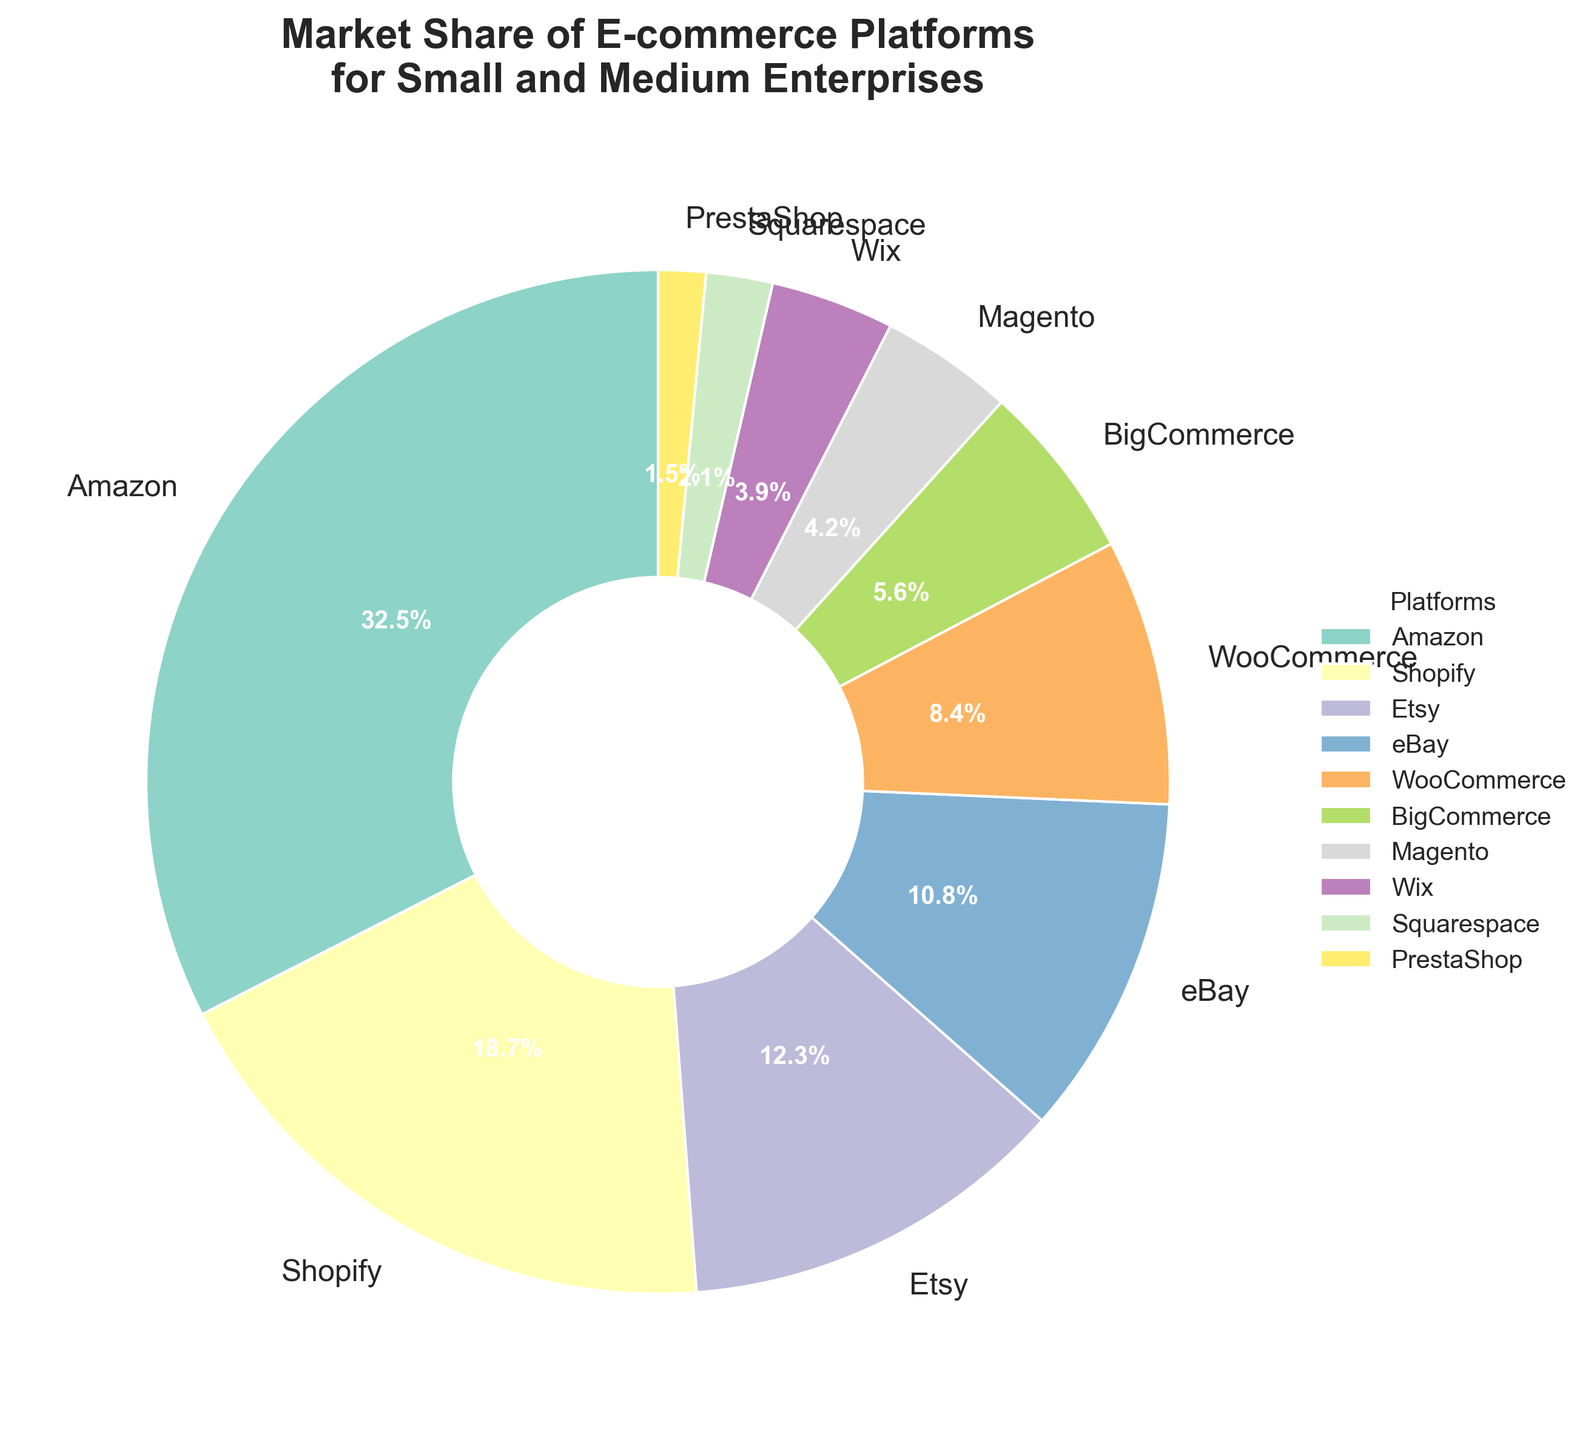Which e-commerce platform has the largest market share? By looking at the pie chart, we can see which platform occupies the largest segment. Amazon is the largest segment in the chart.
Answer: Amazon Which two platforms have a combined market share closest to 50%? We need to sum the market shares of different pairs and find the pair whose sum is closest to 50%. Amazon (32.5%) and Shopify (18.7%) together make 51.2%, which is closest to 50%.
Answer: Amazon and Shopify Is Amazon's market share greater than the combined market share of Etsy and eBay? Calculate the combined market share of Etsy (12.3%) and eBay (10.8%), which is 23.1%. Compare it to Amazon's market share (32.5%). Amazon's market share is greater.
Answer: Yes What is the difference in market share between the leading platform and the smallest platform? Subtract the smallest market share (PrestaShop with 1.5%) from the largest market share (Amazon with 32.5%). The difference is 31.0%.
Answer: 31.0% How many platforms have a market share greater than 10%? Identify the segments in the pie chart with market shares greater than 10%: Amazon (32.5%), Shopify (18.7%), Etsy (12.3%), and eBay (10.8%). There are 4 such platforms.
Answer: 4 Does Shopify have more market share than eBay and WooCommerce combined? Add the market shares of eBay (10.8%) and WooCommerce (8.4%) which total 19.2%. Compare this with Shopify's market share (18.7%). Shopify has slightly less.
Answer: No Which platform has a market share closest to 5%? Look at each segment of the pie chart to find the market share closest to 5%. BigCommerce has a market share of 5.6%, which is closest.
Answer: BigCommerce What is the average market share of the three smallest platforms? Identify the smallest platforms: Squarespace (2.1%), PrestaShop (1.5%), and Wix (3.9%). Calculate their average by summing them up (2.1 + 1.5 + 3.9 = 7.5) and dividing by 3. The average is 2.5%.
Answer: 2.5% Which platform ranks fifth in terms of market share? By visually ranking the segments by size, we find that WooCommerce, with a market share of 8.4%, is the fifth largest.
Answer: WooCommerce 